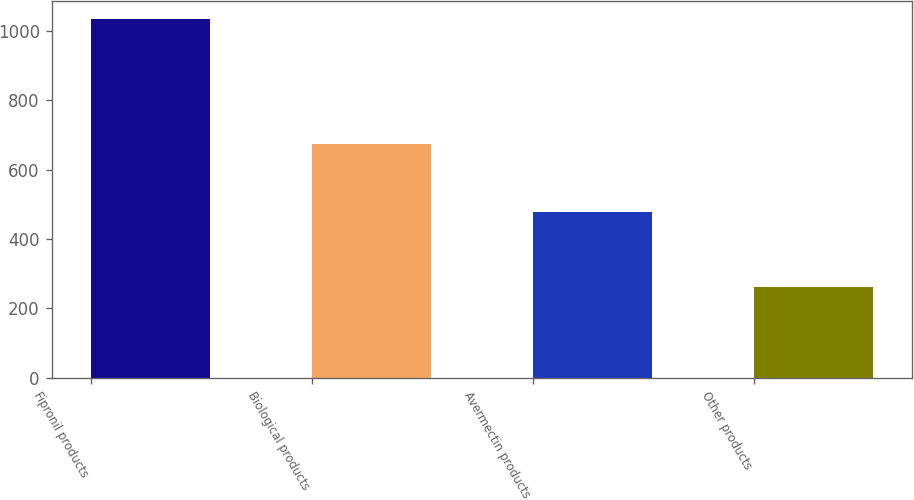Convert chart to OTSL. <chart><loc_0><loc_0><loc_500><loc_500><bar_chart><fcel>Fipronil products<fcel>Biological products<fcel>Avermectin products<fcel>Other products<nl><fcel>1033.3<fcel>674.9<fcel>478.4<fcel>262.2<nl></chart> 